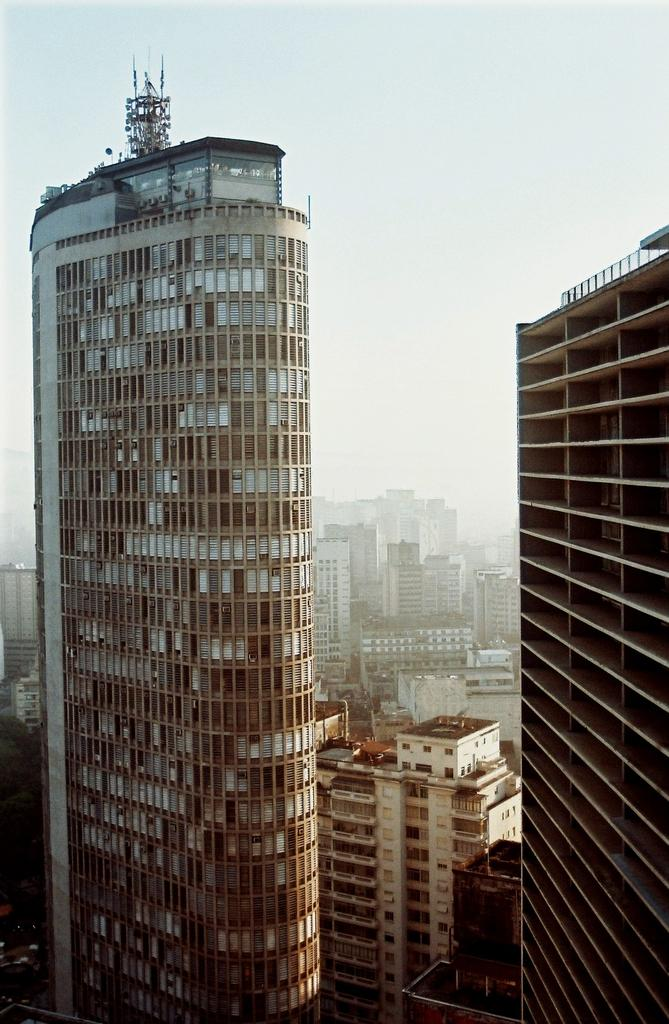What type of structures can be seen in the image? There are buildings in the image. What part of the natural environment is visible in the image? The sky is visible in the background of the image. What are the giants doing in the image? There are no giants present in the image. 